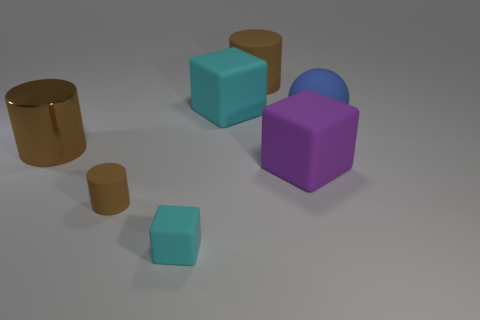There is a cyan thing that is the same material as the big cyan cube; what is its size? small 